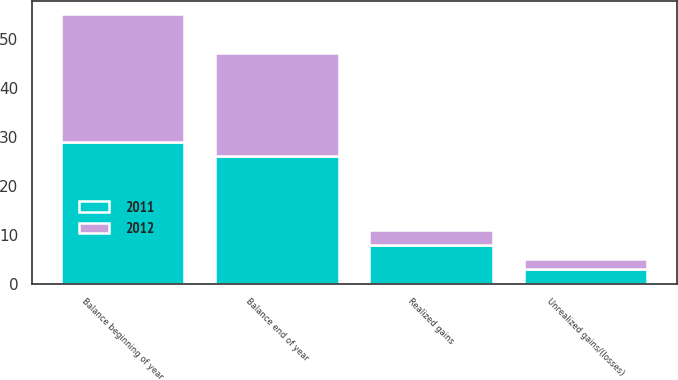<chart> <loc_0><loc_0><loc_500><loc_500><stacked_bar_chart><ecel><fcel>Balance beginning of year<fcel>Realized gains<fcel>Unrealized gains/(losses)<fcel>Balance end of year<nl><fcel>2012<fcel>26<fcel>3<fcel>2<fcel>21<nl><fcel>2011<fcel>29<fcel>8<fcel>3<fcel>26<nl></chart> 